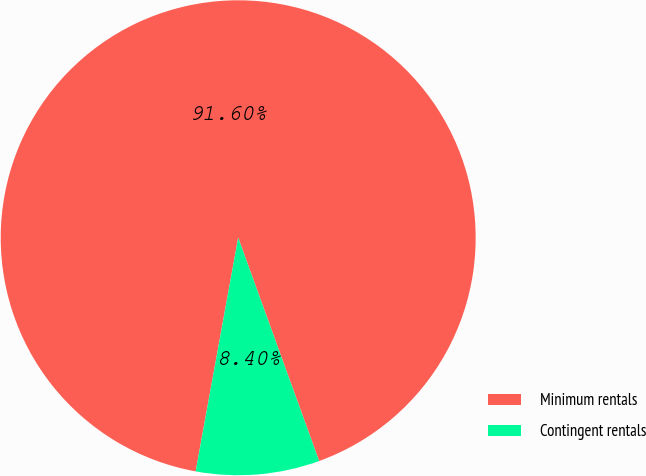<chart> <loc_0><loc_0><loc_500><loc_500><pie_chart><fcel>Minimum rentals<fcel>Contingent rentals<nl><fcel>91.6%<fcel>8.4%<nl></chart> 